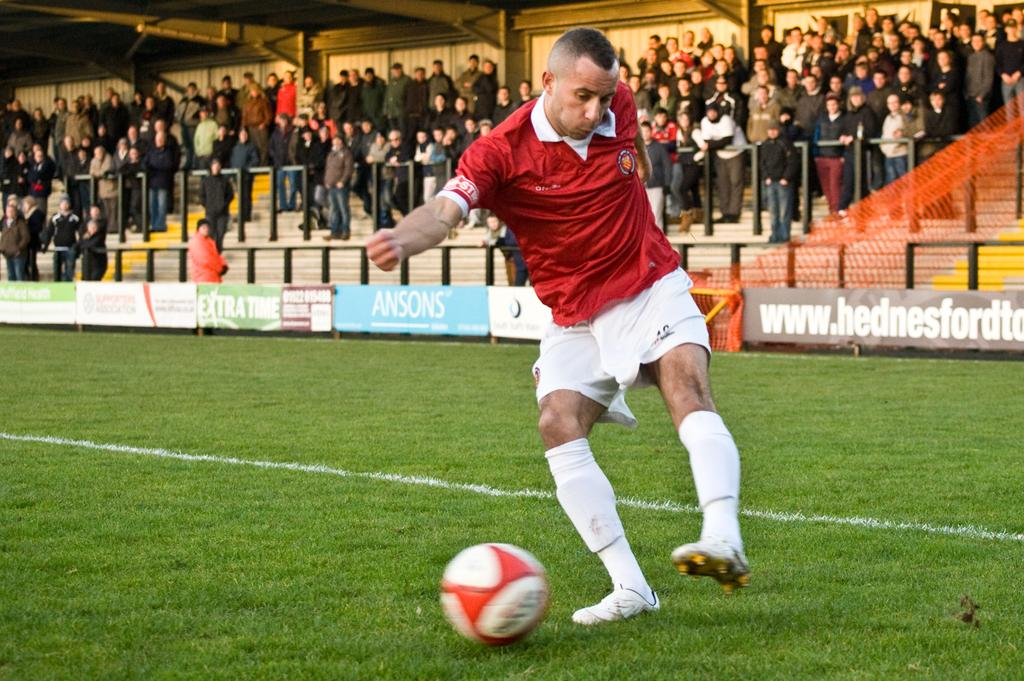<image>
Share a concise interpretation of the image provided. A soccer player is kicking a ball on a field with banners for Ansons' and Extra Time. 